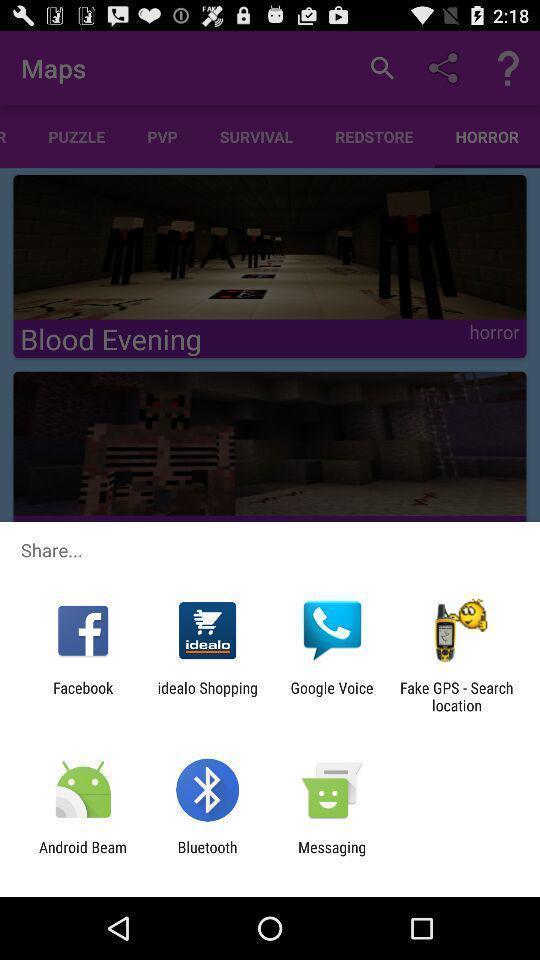Give me a narrative description of this picture. Share page to select through which app to complete action. 